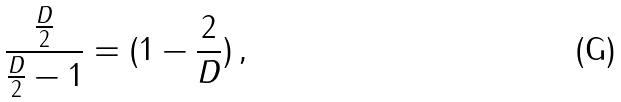<formula> <loc_0><loc_0><loc_500><loc_500>\frac { \frac { D } { 2 } } { \frac { D } { 2 } - 1 } = ( 1 - \frac { 2 } { D } ) \, ,</formula> 